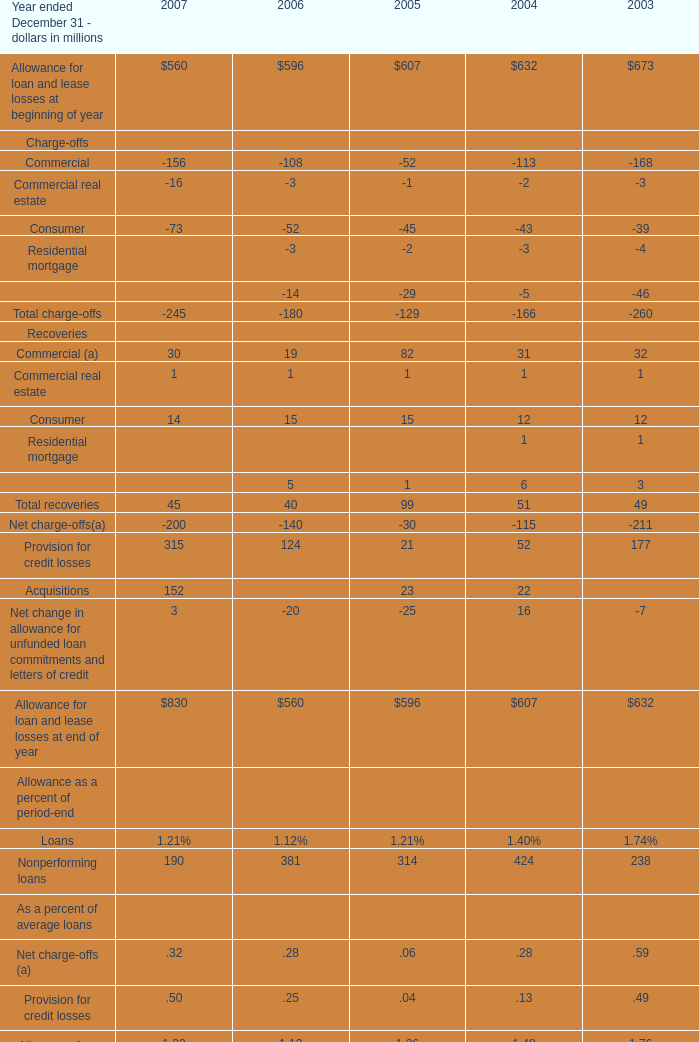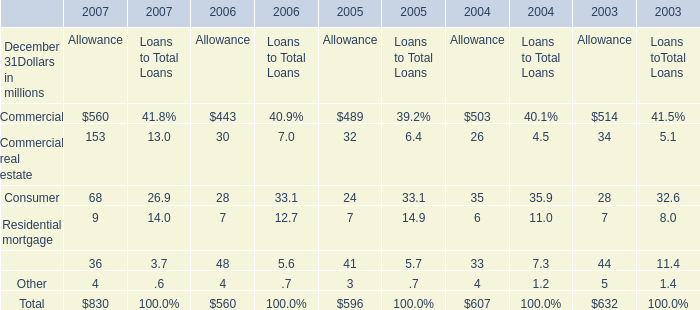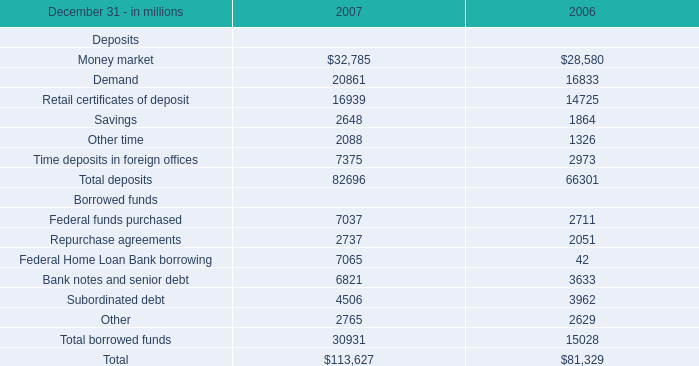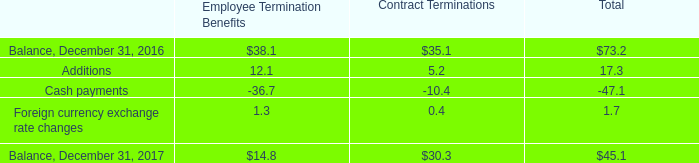What is the growing rate of Residential mortgage in the years with the least consumer? (in %) 
Computations: ((7 - 6) / 6)
Answer: 0.16667. 